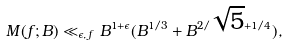Convert formula to latex. <formula><loc_0><loc_0><loc_500><loc_500>M ( f ; B ) \ll _ { \epsilon , \, f } B ^ { 1 + \epsilon } ( B ^ { 1 / 3 } + B ^ { 2 / \sqrt { 5 } + 1 / 4 } ) ,</formula> 